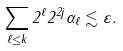<formula> <loc_0><loc_0><loc_500><loc_500>\sum _ { \ell \leq k } 2 ^ { \ell } 2 ^ { 2 j } \alpha _ { \ell } \lesssim \varepsilon .</formula> 